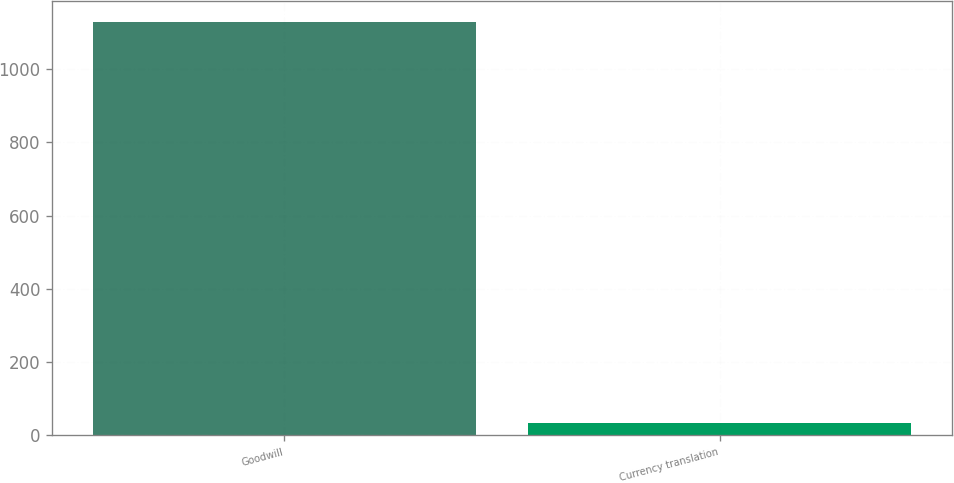<chart> <loc_0><loc_0><loc_500><loc_500><bar_chart><fcel>Goodwill<fcel>Currency translation<nl><fcel>1128.6<fcel>34.5<nl></chart> 